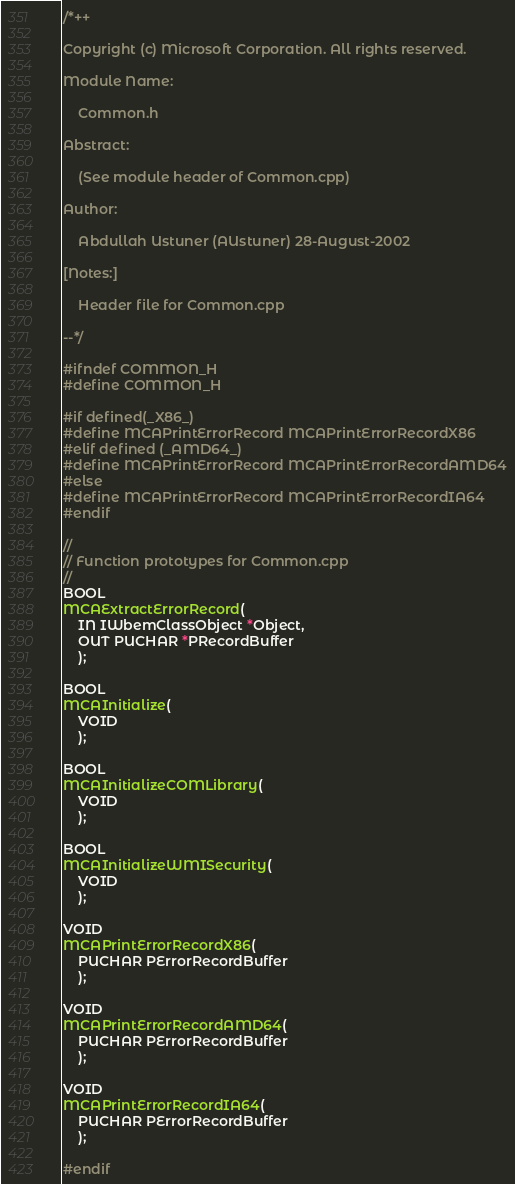<code> <loc_0><loc_0><loc_500><loc_500><_C_>/*++

Copyright (c) Microsoft Corporation. All rights reserved.

Module Name:

    Common.h

Abstract:

    (See module header of Common.cpp)
    
Author:

    Abdullah Ustuner (AUstuner) 28-August-2002

[Notes:]

    Header file for Common.cpp
        
--*/

#ifndef COMMON_H
#define COMMON_H

#if defined(_X86_)
#define MCAPrintErrorRecord MCAPrintErrorRecordX86
#elif defined (_AMD64_)
#define MCAPrintErrorRecord MCAPrintErrorRecordAMD64
#else
#define MCAPrintErrorRecord MCAPrintErrorRecordIA64
#endif

//
// Function prototypes for Common.cpp
//
BOOL
MCAExtractErrorRecord(
    IN IWbemClassObject *Object,
    OUT PUCHAR *PRecordBuffer    
	);

BOOL
MCAInitialize(
	VOID
	);

BOOL
MCAInitializeCOMLibrary(
	VOID
	);

BOOL
MCAInitializeWMISecurity(
	VOID
	);

VOID
MCAPrintErrorRecordX86(
	PUCHAR PErrorRecordBuffer
	);

VOID
MCAPrintErrorRecordAMD64(
	PUCHAR PErrorRecordBuffer
	);

VOID
MCAPrintErrorRecordIA64(
	PUCHAR PErrorRecordBuffer
	);

#endif
</code> 